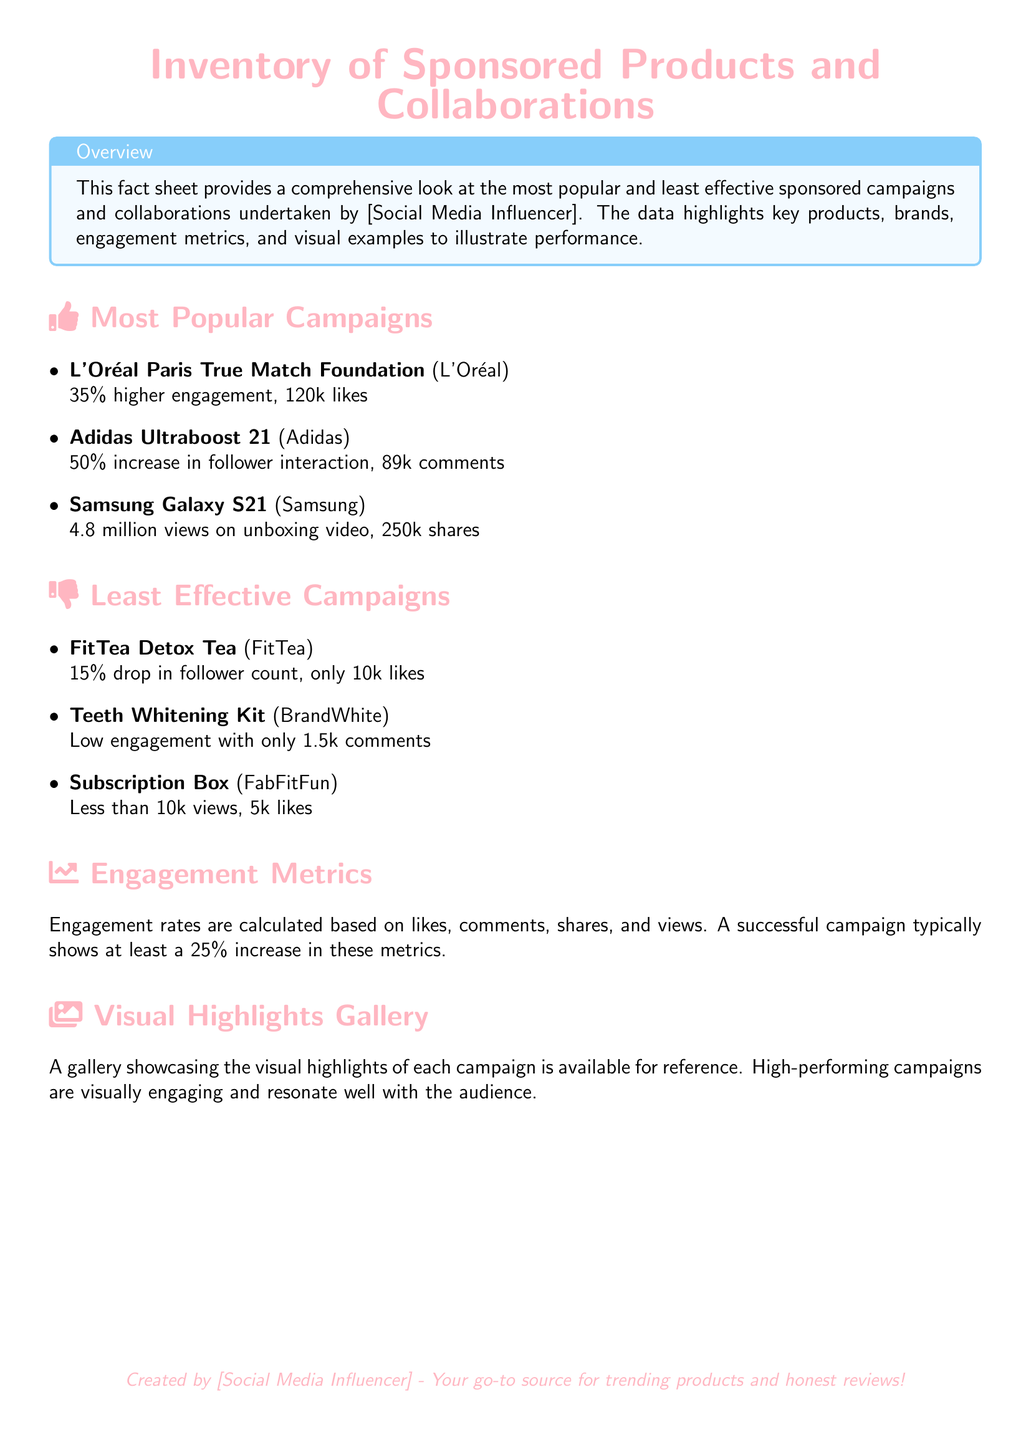What is the most popular campaign? The most popular campaign mentioned in the document is "L'Oréal Paris True Match Foundation".
Answer: L'Oréal Paris True Match Foundation What is the engagement increase for Adidas Ultraboost 21? The document states that the Adidas Ultraboost 21 had a 50% increase in follower interaction.
Answer: 50% How many views did the Samsung Galaxy S21 unboxing video have? According to the document, the unboxing video for the Samsung Galaxy S21 had 4.8 million views.
Answer: 4.8 million views Which campaign had a 15% drop in follower count? The document specifies that the FitTea Detox Tea campaign resulted in a 15% drop in follower count.
Answer: FitTea Detox Tea What is the minimum engagement rate for a successful campaign? The document indicates that a successful campaign typically shows at least a 25% increase in engagement metrics.
Answer: 25% Which product from the least effective campaigns had only 1.5k comments? The Teeth Whitening Kit from BrandWhite had low engagement with only 1.5k comments according to the document.
Answer: Teeth Whitening Kit What is showcased in the visual highlights gallery? The visual highlights gallery showcases high-performing campaign visuals that are engaging.
Answer: High-performing campaign visuals How many likes did the subscription box campaign receive? The document states that the Subscription Box campaign received less than 10k likes.
Answer: Less than 10k likes What color is used for the document title? The title of the document is in influencer pink color.
Answer: influencer pink 